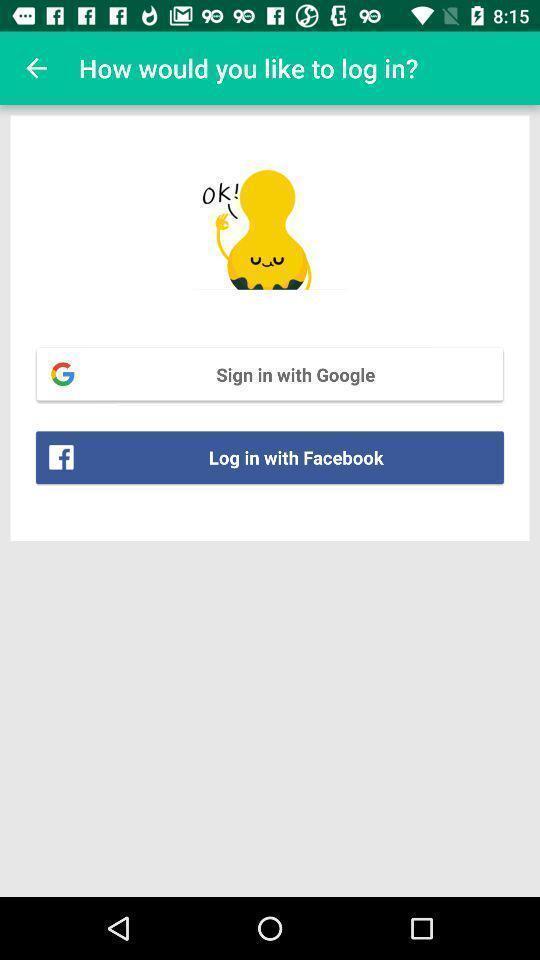Describe the content in this image. Welcome page of a social application. 